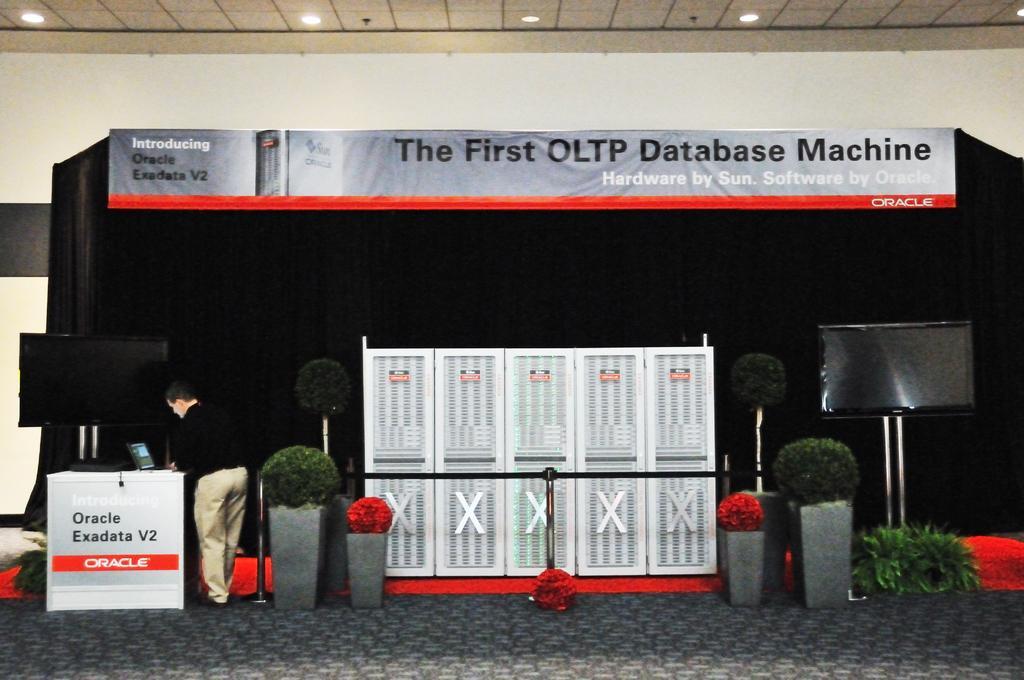Could you give a brief overview of what you see in this image? This image consists of bushes in the middle. There are screens on the left side and right side. There is a man on the left side. There is a laptop on the left side. There are lights at the top. There is a banner in the middle. 